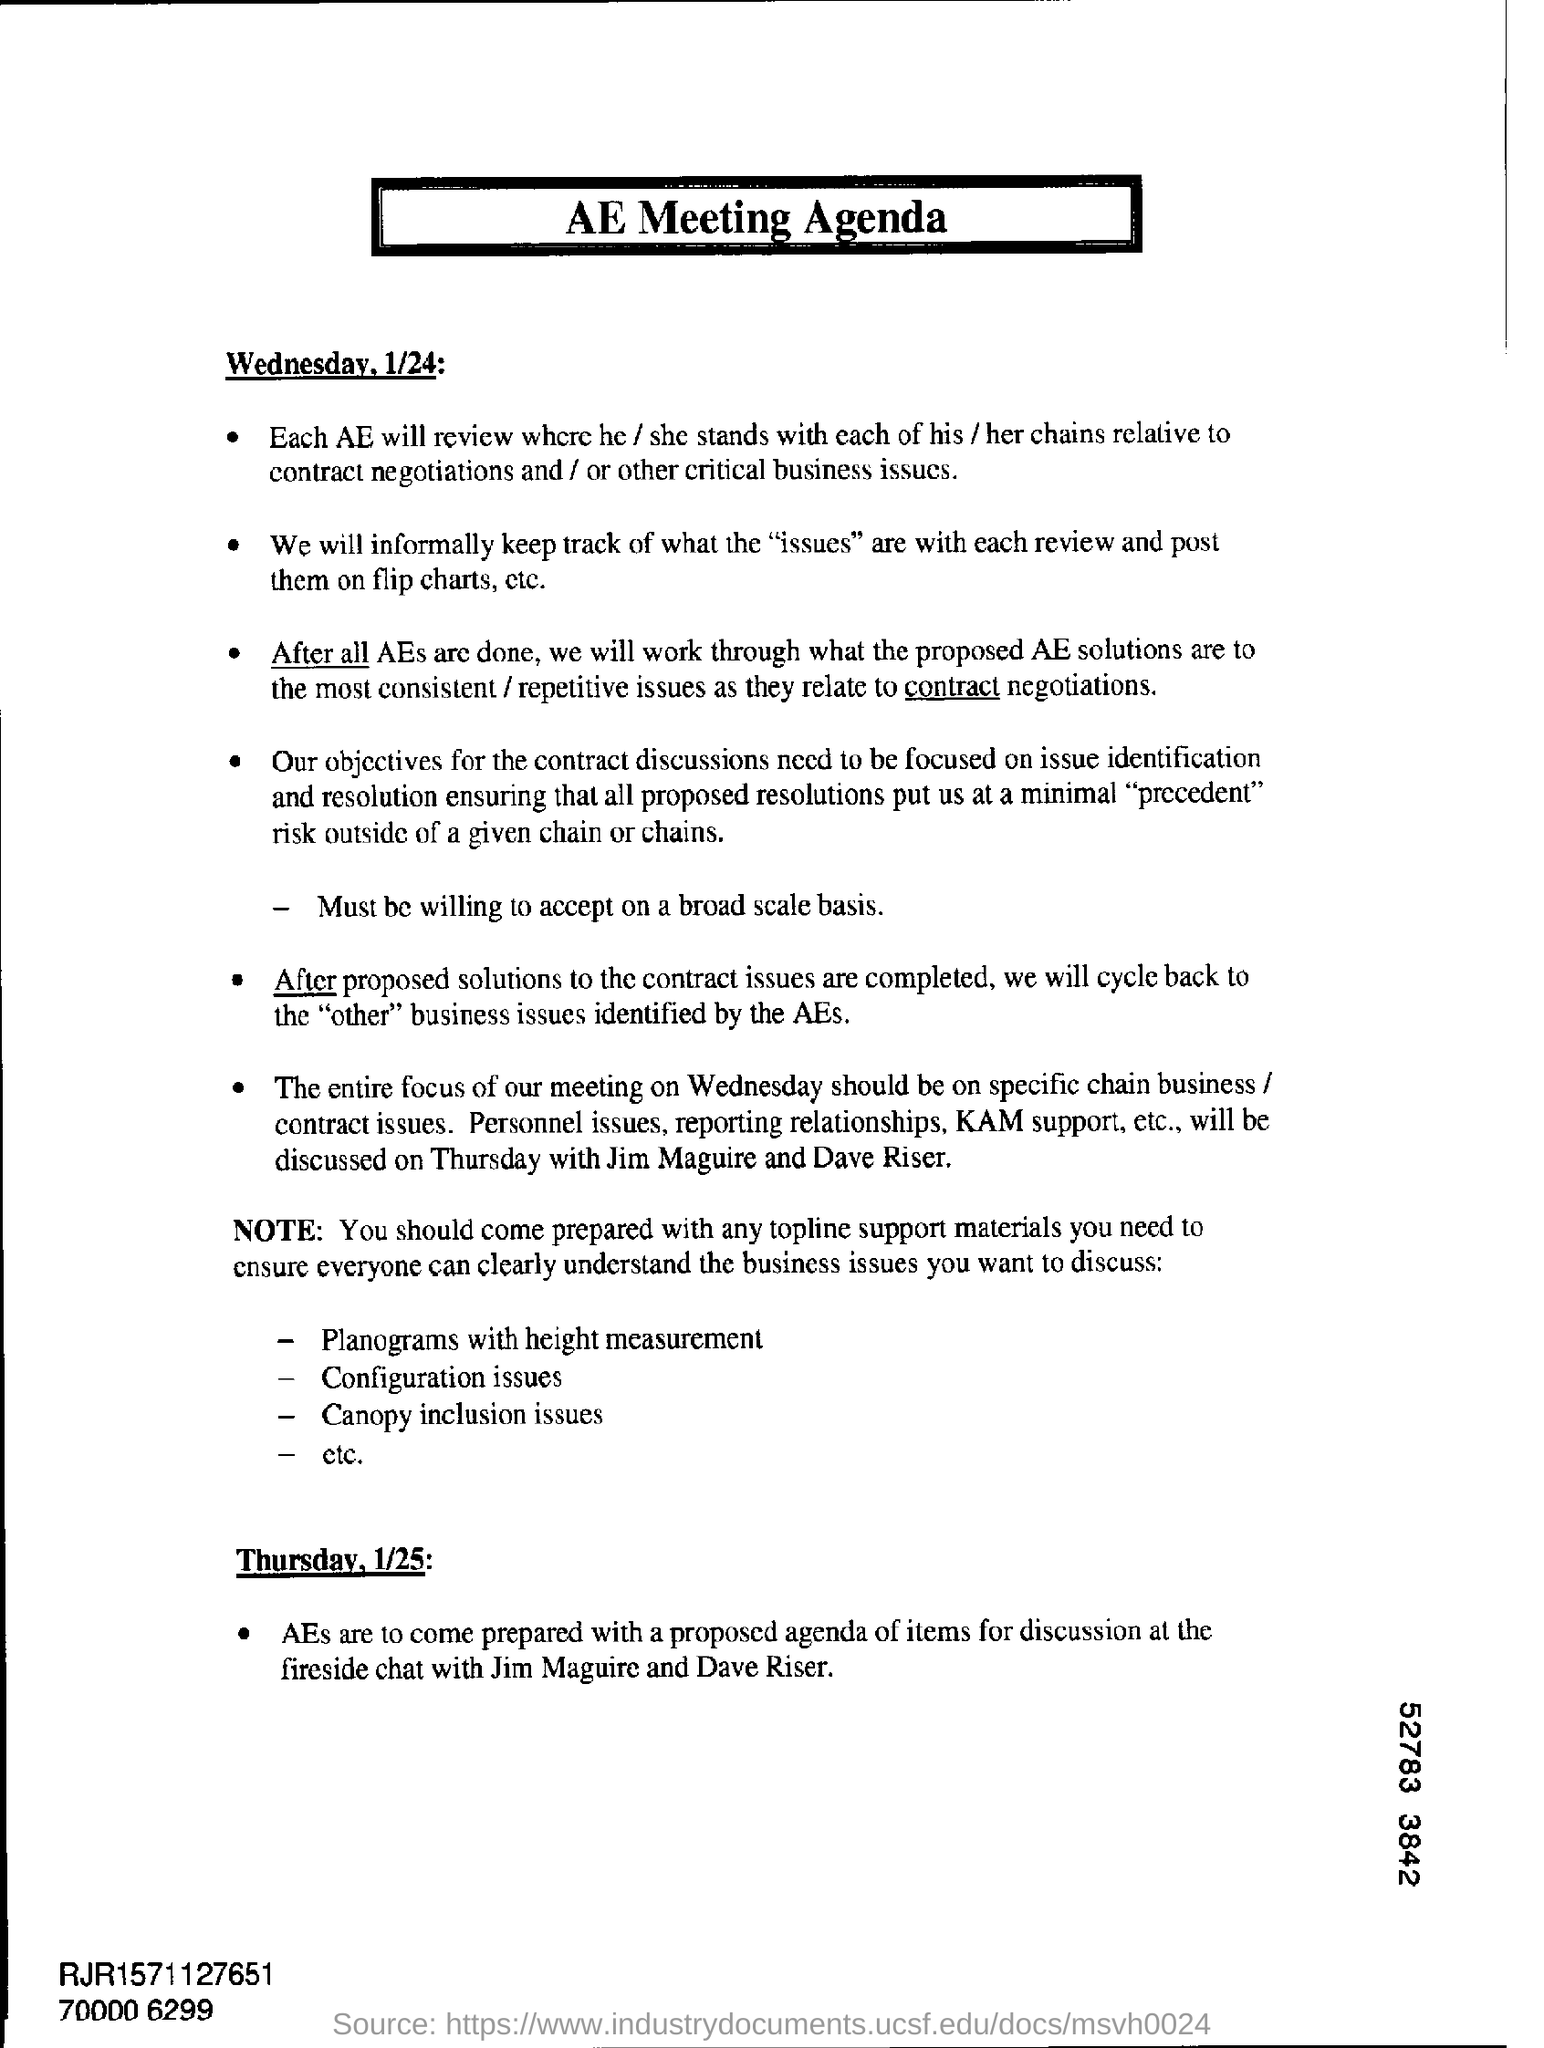List a handful of essential elements in this visual. The digit shown in the bottom right corner of the number 52783 is 3. 